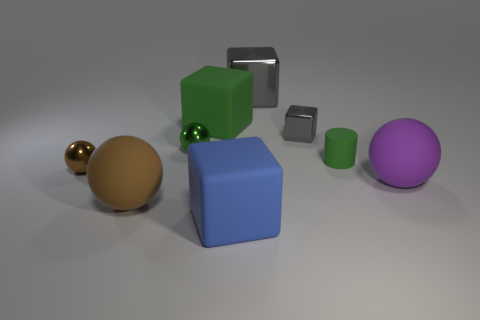What shape is the large rubber object that is the same color as the tiny cylinder?
Make the answer very short. Cube. The metallic thing that is the same color as the tiny cylinder is what size?
Give a very brief answer. Small. Does the cylinder have the same size as the cube in front of the small green rubber cylinder?
Your answer should be very brief. No. What material is the big ball right of the matte sphere to the left of the big purple object?
Provide a succinct answer. Rubber. There is a matte cube in front of the rubber ball that is right of the gray cube that is right of the big gray object; what size is it?
Your answer should be compact. Large. There is a large brown thing; is it the same shape as the small brown object that is to the left of the large gray block?
Your response must be concise. Yes. What is the material of the tiny block?
Your answer should be compact. Metal. What number of matte objects are either small gray objects or large green cubes?
Your answer should be very brief. 1. Is the number of tiny green matte cylinders in front of the brown metal sphere less than the number of large brown things behind the tiny cube?
Your response must be concise. No. Are there any large brown things right of the big ball that is right of the large matte cube behind the large blue object?
Provide a succinct answer. No. 